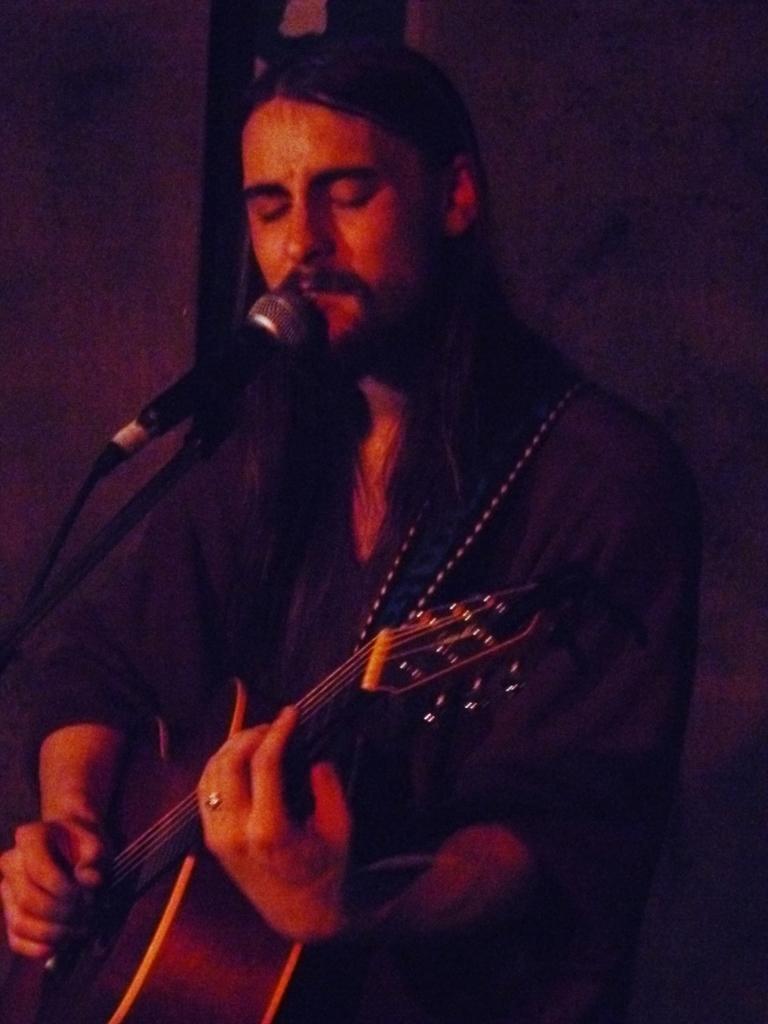How would you summarize this image in a sentence or two? In the image we can see there is a person who is standing and holding guitar in his hand and in front of him there is mic with a stand. 